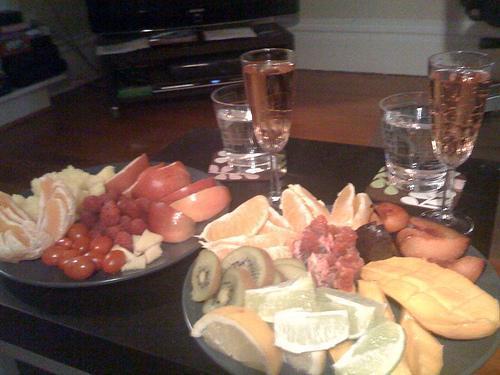How many plates are there?
Give a very brief answer. 2. 